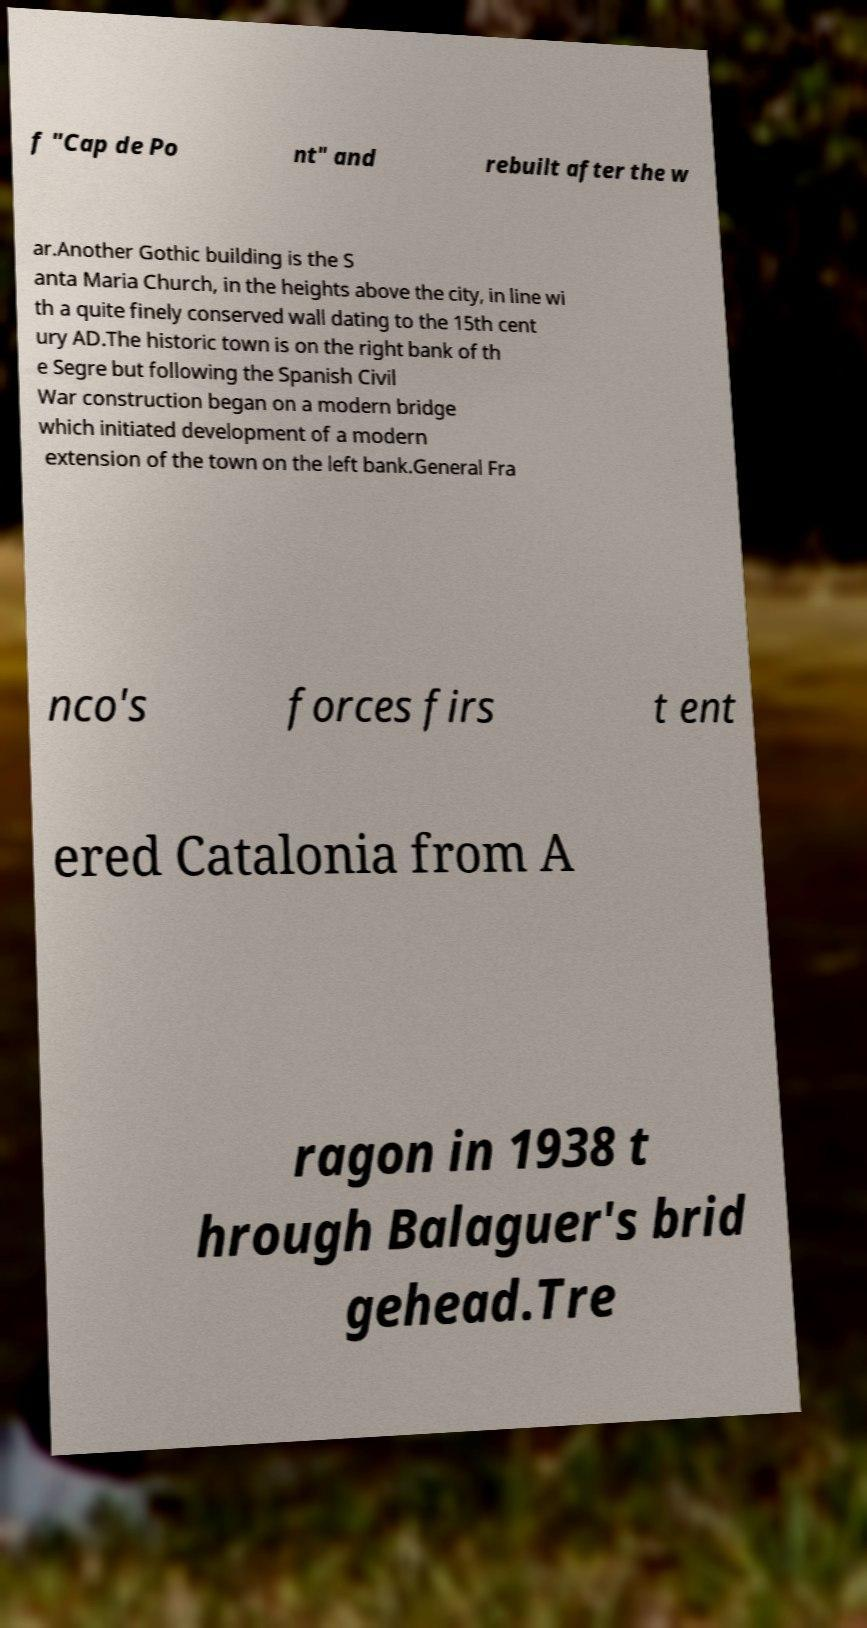Can you read and provide the text displayed in the image?This photo seems to have some interesting text. Can you extract and type it out for me? f "Cap de Po nt" and rebuilt after the w ar.Another Gothic building is the S anta Maria Church, in the heights above the city, in line wi th a quite finely conserved wall dating to the 15th cent ury AD.The historic town is on the right bank of th e Segre but following the Spanish Civil War construction began on a modern bridge which initiated development of a modern extension of the town on the left bank.General Fra nco's forces firs t ent ered Catalonia from A ragon in 1938 t hrough Balaguer's brid gehead.Tre 